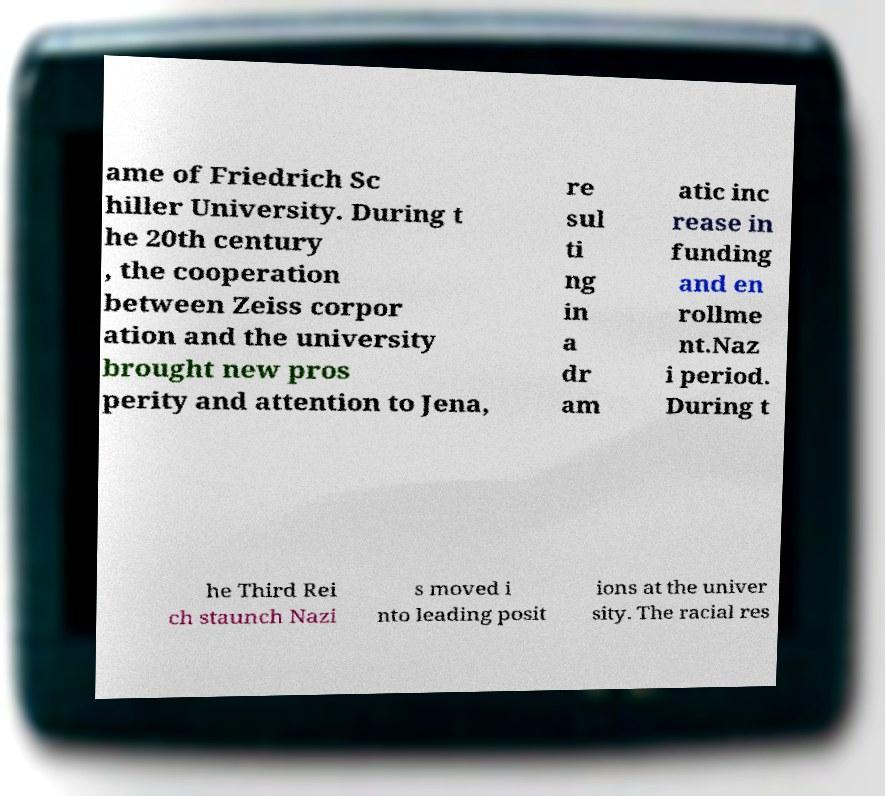Could you extract and type out the text from this image? ame of Friedrich Sc hiller University. During t he 20th century , the cooperation between Zeiss corpor ation and the university brought new pros perity and attention to Jena, re sul ti ng in a dr am atic inc rease in funding and en rollme nt.Naz i period. During t he Third Rei ch staunch Nazi s moved i nto leading posit ions at the univer sity. The racial res 